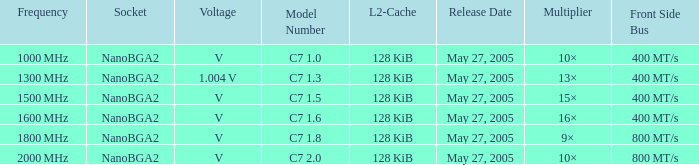What is the front side bus for model number c7 400 MT/s. 